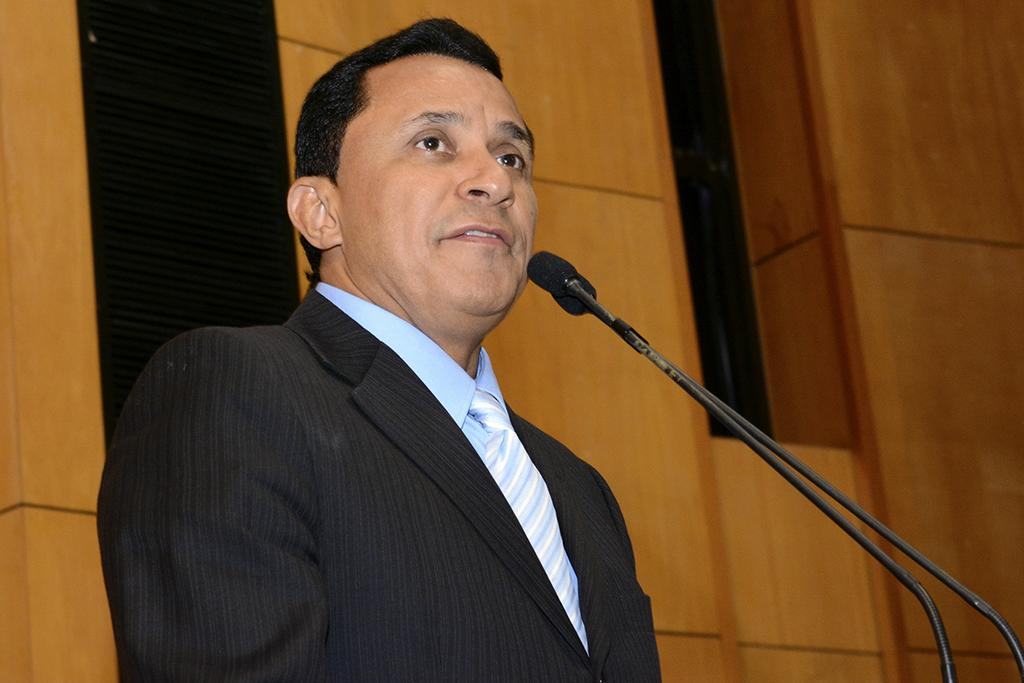Who is present in the image? There is a man in the image. What is the man doing in the image? The man is standing at the microphones. What can be seen in the background of the image? There is a wall in the background of the image. How much money is on the tray in the image? There is no tray or money present in the image. What type of border is depicted in the image? There is no border depicted in the image; it only features a man standing at the microphones and a wall in the background. 